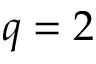Convert formula to latex. <formula><loc_0><loc_0><loc_500><loc_500>q = 2</formula> 